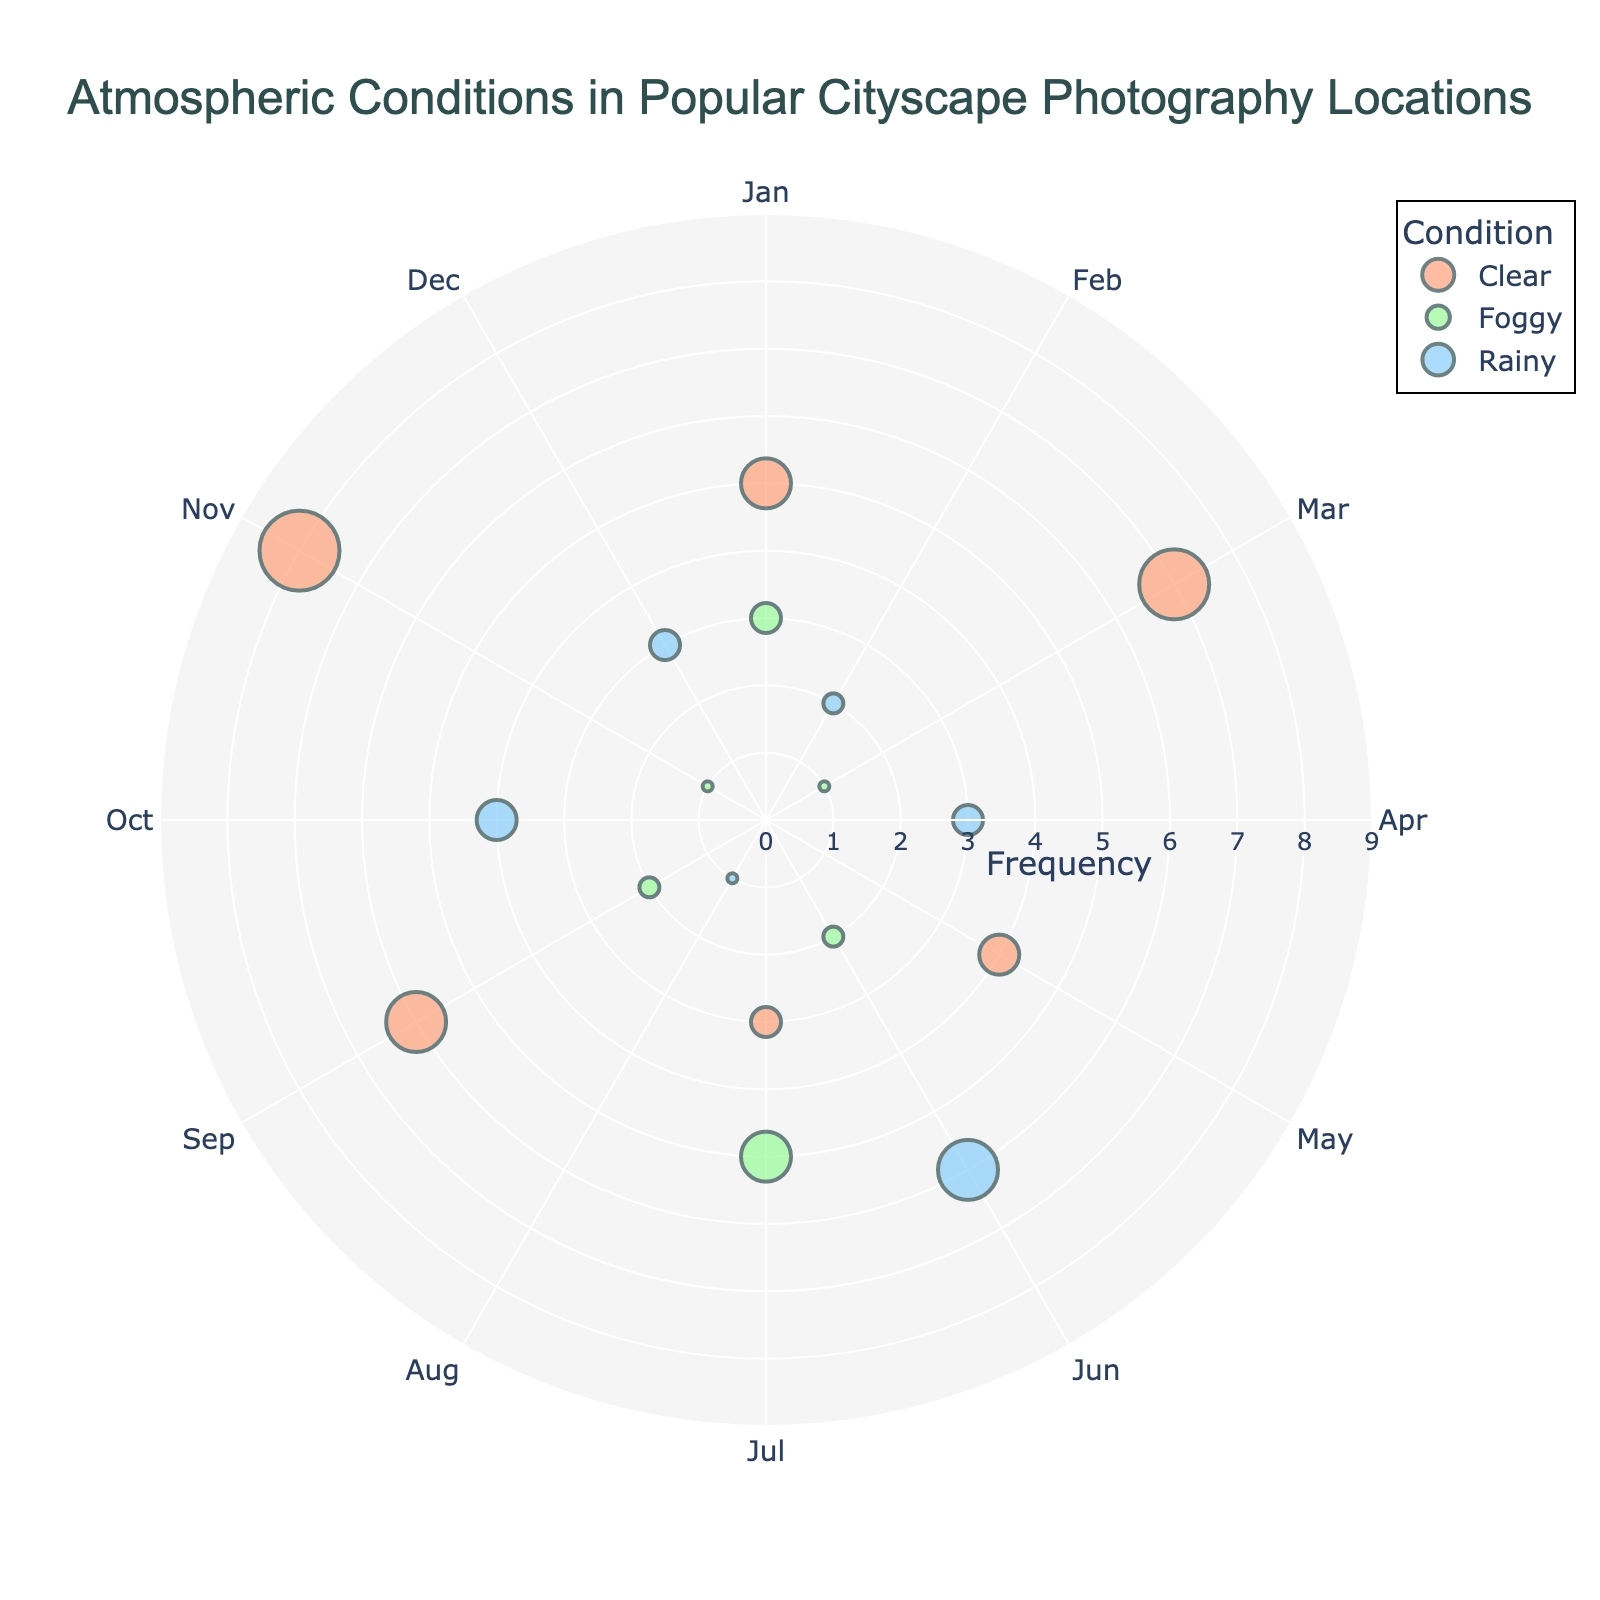What is the title of the figure? The title is located at the top of the figure, generally larger and more prominent than other text elements. It is formatted to attract attention and provide a summary of the content.
Answer: Atmospheric Conditions in Popular Cityscape Photography Locations Which month shows the highest frequency of clear conditions? Look at the markers indicating clear conditions (usually color-coded) and compare the different angles representing each month. Identify the month with the highest radial distance for the clear condition.
Answer: November How many different atmospheric conditions are plotted in the figure? Identify the unique markers or labels representing different atmospheric conditions from the legend or directly from the figure.
Answer: 3 Which location has the highest frequency of foggy conditions in the data? Refer to the markers indicating foggy conditions and note the locations labeled with the highest radial distance for foggy conditions.
Answer: San Francisco What is the total frequency of foggy conditions across all locations? Sum up the radial distances (frequencies) of all markers corresponding to foggy conditions. Check all relevant markers and their frequencies.
Answer: 11 What is the difference in frequency between the most and least frequent rainy conditions? Identify the maximum and minimum radial distances (frequencies) among the rainy conditions. Subtract the minimum from the maximum.
Answer: 6 Which location shows the highest variety of atmospheric conditions? Assess each location based on the count of different atmospheric conditions plotted for them. The location with all three conditions (clear, foggy, rainy) appearing will have the highest variety.
Answer: London During which month does Tokyo experience the highest frequency of rainy conditions? Look at the markers for Tokyo and identify which month (represented by a specific angle) has the highest radial value (frequency) for rainy conditions.
Answer: June How does the frequency of clear conditions in Paris compare with Sydney? Compare the radial distances (frequencies) of the clear condition markers for Paris and Sydney respectively. Note which is greater.
Answer: Sydney Is there a month with no recorded foggy conditions for any location? Check each month represented by different angles for the presence of markers indicating foggy conditions. Identify if any month lacks such markers.
Answer: March 